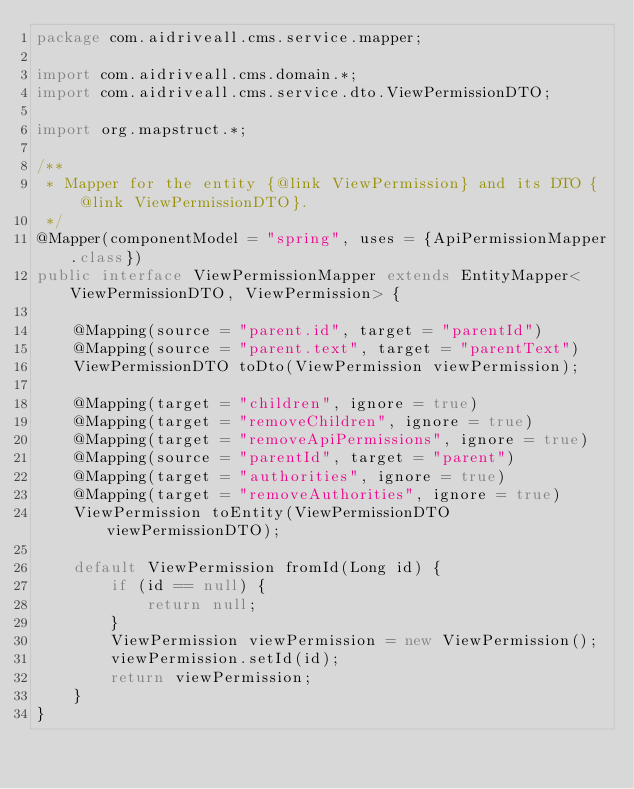Convert code to text. <code><loc_0><loc_0><loc_500><loc_500><_Java_>package com.aidriveall.cms.service.mapper;

import com.aidriveall.cms.domain.*;
import com.aidriveall.cms.service.dto.ViewPermissionDTO;

import org.mapstruct.*;

/**
 * Mapper for the entity {@link ViewPermission} and its DTO {@link ViewPermissionDTO}.
 */
@Mapper(componentModel = "spring", uses = {ApiPermissionMapper.class})
public interface ViewPermissionMapper extends EntityMapper<ViewPermissionDTO, ViewPermission> {

    @Mapping(source = "parent.id", target = "parentId")
    @Mapping(source = "parent.text", target = "parentText")
    ViewPermissionDTO toDto(ViewPermission viewPermission);

    @Mapping(target = "children", ignore = true)
    @Mapping(target = "removeChildren", ignore = true)
    @Mapping(target = "removeApiPermissions", ignore = true)
    @Mapping(source = "parentId", target = "parent")
    @Mapping(target = "authorities", ignore = true)
    @Mapping(target = "removeAuthorities", ignore = true)
    ViewPermission toEntity(ViewPermissionDTO viewPermissionDTO);

    default ViewPermission fromId(Long id) {
        if (id == null) {
            return null;
        }
        ViewPermission viewPermission = new ViewPermission();
        viewPermission.setId(id);
        return viewPermission;
    }
}
</code> 